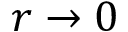<formula> <loc_0><loc_0><loc_500><loc_500>r \rightarrow 0</formula> 